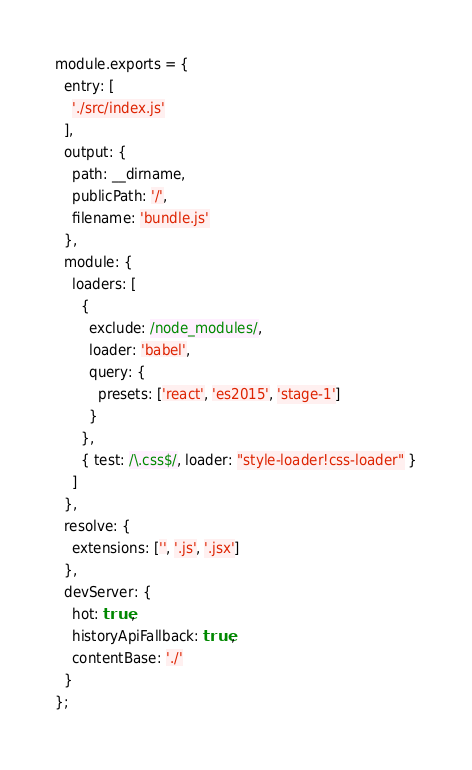<code> <loc_0><loc_0><loc_500><loc_500><_JavaScript_>module.exports = {
  entry: [
    './src/index.js'
  ],
  output: {
    path: __dirname,
    publicPath: '/',
    filename: 'bundle.js'
  },
  module: {
    loaders: [
      {
        exclude: /node_modules/,
        loader: 'babel',
        query: {
          presets: ['react', 'es2015', 'stage-1']
        }
      },
      { test: /\.css$/, loader: "style-loader!css-loader" }
    ]
  },
  resolve: {
    extensions: ['', '.js', '.jsx']
  },
  devServer: {
    hot: true,
    historyApiFallback: true,
    contentBase: './'
  }
};
</code> 